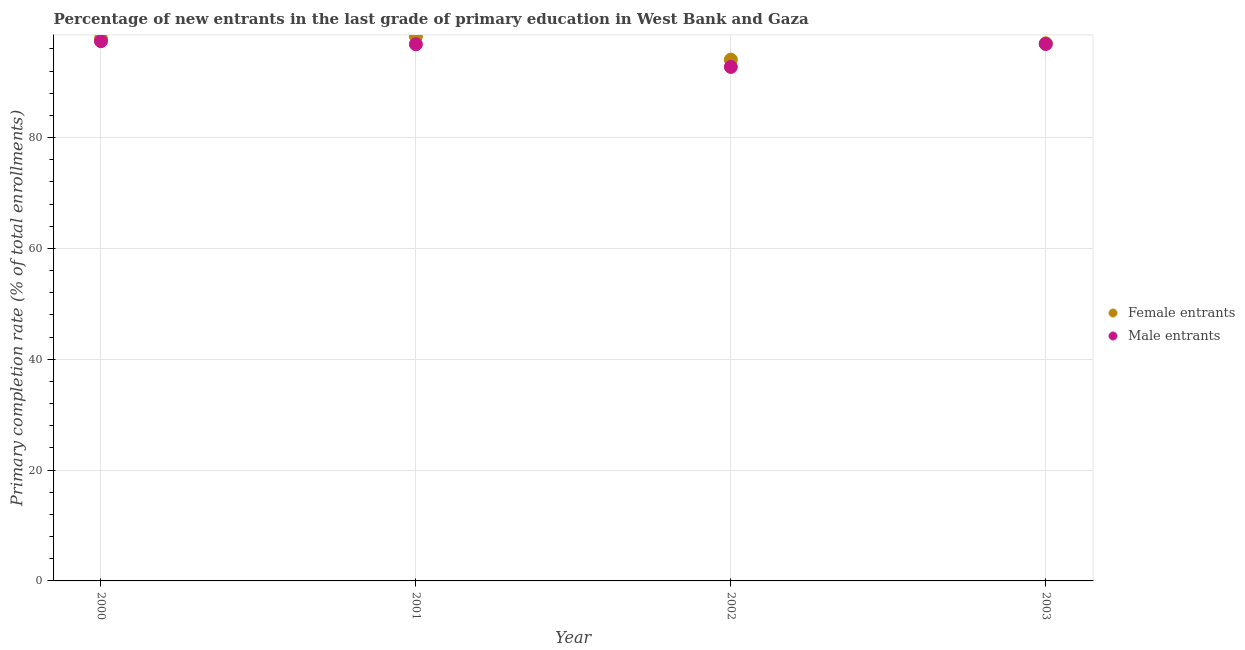What is the primary completion rate of male entrants in 2002?
Provide a short and direct response. 92.76. Across all years, what is the maximum primary completion rate of male entrants?
Provide a short and direct response. 97.41. Across all years, what is the minimum primary completion rate of female entrants?
Your answer should be compact. 94.08. In which year was the primary completion rate of male entrants maximum?
Provide a short and direct response. 2000. What is the total primary completion rate of female entrants in the graph?
Keep it short and to the point. 387.25. What is the difference between the primary completion rate of male entrants in 2000 and that in 2003?
Your response must be concise. 0.51. What is the difference between the primary completion rate of male entrants in 2001 and the primary completion rate of female entrants in 2000?
Your answer should be compact. -1.02. What is the average primary completion rate of female entrants per year?
Your answer should be very brief. 96.81. In the year 2000, what is the difference between the primary completion rate of male entrants and primary completion rate of female entrants?
Your answer should be very brief. -0.47. In how many years, is the primary completion rate of male entrants greater than 52 %?
Offer a very short reply. 4. What is the ratio of the primary completion rate of female entrants in 2001 to that in 2002?
Your answer should be compact. 1.04. Is the primary completion rate of female entrants in 2000 less than that in 2003?
Keep it short and to the point. No. Is the difference between the primary completion rate of female entrants in 2000 and 2001 greater than the difference between the primary completion rate of male entrants in 2000 and 2001?
Ensure brevity in your answer.  No. What is the difference between the highest and the second highest primary completion rate of female entrants?
Provide a succinct answer. 0.39. What is the difference between the highest and the lowest primary completion rate of female entrants?
Your answer should be compact. 4.19. In how many years, is the primary completion rate of male entrants greater than the average primary completion rate of male entrants taken over all years?
Offer a very short reply. 3. Is the sum of the primary completion rate of male entrants in 2000 and 2002 greater than the maximum primary completion rate of female entrants across all years?
Offer a very short reply. Yes. Is the primary completion rate of female entrants strictly less than the primary completion rate of male entrants over the years?
Keep it short and to the point. No. How many dotlines are there?
Give a very brief answer. 2. What is the difference between two consecutive major ticks on the Y-axis?
Your answer should be compact. 20. Are the values on the major ticks of Y-axis written in scientific E-notation?
Your answer should be very brief. No. Does the graph contain any zero values?
Ensure brevity in your answer.  No. Where does the legend appear in the graph?
Provide a succinct answer. Center right. How many legend labels are there?
Your answer should be compact. 2. What is the title of the graph?
Provide a succinct answer. Percentage of new entrants in the last grade of primary education in West Bank and Gaza. What is the label or title of the X-axis?
Give a very brief answer. Year. What is the label or title of the Y-axis?
Your answer should be very brief. Primary completion rate (% of total enrollments). What is the Primary completion rate (% of total enrollments) of Female entrants in 2000?
Offer a very short reply. 97.88. What is the Primary completion rate (% of total enrollments) in Male entrants in 2000?
Ensure brevity in your answer.  97.41. What is the Primary completion rate (% of total enrollments) of Female entrants in 2001?
Offer a terse response. 98.27. What is the Primary completion rate (% of total enrollments) of Male entrants in 2001?
Ensure brevity in your answer.  96.86. What is the Primary completion rate (% of total enrollments) in Female entrants in 2002?
Provide a succinct answer. 94.08. What is the Primary completion rate (% of total enrollments) in Male entrants in 2002?
Your answer should be very brief. 92.76. What is the Primary completion rate (% of total enrollments) of Female entrants in 2003?
Provide a succinct answer. 97.03. What is the Primary completion rate (% of total enrollments) in Male entrants in 2003?
Make the answer very short. 96.9. Across all years, what is the maximum Primary completion rate (% of total enrollments) of Female entrants?
Provide a succinct answer. 98.27. Across all years, what is the maximum Primary completion rate (% of total enrollments) of Male entrants?
Your response must be concise. 97.41. Across all years, what is the minimum Primary completion rate (% of total enrollments) in Female entrants?
Your answer should be very brief. 94.08. Across all years, what is the minimum Primary completion rate (% of total enrollments) of Male entrants?
Your answer should be compact. 92.76. What is the total Primary completion rate (% of total enrollments) of Female entrants in the graph?
Ensure brevity in your answer.  387.25. What is the total Primary completion rate (% of total enrollments) in Male entrants in the graph?
Your answer should be compact. 383.92. What is the difference between the Primary completion rate (% of total enrollments) in Female entrants in 2000 and that in 2001?
Provide a succinct answer. -0.39. What is the difference between the Primary completion rate (% of total enrollments) of Male entrants in 2000 and that in 2001?
Keep it short and to the point. 0.55. What is the difference between the Primary completion rate (% of total enrollments) in Female entrants in 2000 and that in 2002?
Your response must be concise. 3.8. What is the difference between the Primary completion rate (% of total enrollments) in Male entrants in 2000 and that in 2002?
Give a very brief answer. 4.64. What is the difference between the Primary completion rate (% of total enrollments) of Female entrants in 2000 and that in 2003?
Offer a terse response. 0.85. What is the difference between the Primary completion rate (% of total enrollments) in Male entrants in 2000 and that in 2003?
Offer a very short reply. 0.51. What is the difference between the Primary completion rate (% of total enrollments) in Female entrants in 2001 and that in 2002?
Offer a terse response. 4.19. What is the difference between the Primary completion rate (% of total enrollments) in Male entrants in 2001 and that in 2002?
Provide a succinct answer. 4.09. What is the difference between the Primary completion rate (% of total enrollments) of Female entrants in 2001 and that in 2003?
Provide a short and direct response. 1.25. What is the difference between the Primary completion rate (% of total enrollments) of Male entrants in 2001 and that in 2003?
Ensure brevity in your answer.  -0.04. What is the difference between the Primary completion rate (% of total enrollments) of Female entrants in 2002 and that in 2003?
Make the answer very short. -2.95. What is the difference between the Primary completion rate (% of total enrollments) in Male entrants in 2002 and that in 2003?
Your answer should be compact. -4.13. What is the difference between the Primary completion rate (% of total enrollments) of Female entrants in 2000 and the Primary completion rate (% of total enrollments) of Male entrants in 2001?
Offer a very short reply. 1.02. What is the difference between the Primary completion rate (% of total enrollments) of Female entrants in 2000 and the Primary completion rate (% of total enrollments) of Male entrants in 2002?
Keep it short and to the point. 5.11. What is the difference between the Primary completion rate (% of total enrollments) of Female entrants in 2000 and the Primary completion rate (% of total enrollments) of Male entrants in 2003?
Offer a terse response. 0.98. What is the difference between the Primary completion rate (% of total enrollments) of Female entrants in 2001 and the Primary completion rate (% of total enrollments) of Male entrants in 2002?
Your response must be concise. 5.51. What is the difference between the Primary completion rate (% of total enrollments) of Female entrants in 2001 and the Primary completion rate (% of total enrollments) of Male entrants in 2003?
Your answer should be compact. 1.38. What is the difference between the Primary completion rate (% of total enrollments) in Female entrants in 2002 and the Primary completion rate (% of total enrollments) in Male entrants in 2003?
Give a very brief answer. -2.82. What is the average Primary completion rate (% of total enrollments) of Female entrants per year?
Your response must be concise. 96.81. What is the average Primary completion rate (% of total enrollments) in Male entrants per year?
Your answer should be very brief. 95.98. In the year 2000, what is the difference between the Primary completion rate (% of total enrollments) of Female entrants and Primary completion rate (% of total enrollments) of Male entrants?
Ensure brevity in your answer.  0.47. In the year 2001, what is the difference between the Primary completion rate (% of total enrollments) in Female entrants and Primary completion rate (% of total enrollments) in Male entrants?
Offer a terse response. 1.42. In the year 2002, what is the difference between the Primary completion rate (% of total enrollments) in Female entrants and Primary completion rate (% of total enrollments) in Male entrants?
Your response must be concise. 1.31. In the year 2003, what is the difference between the Primary completion rate (% of total enrollments) of Female entrants and Primary completion rate (% of total enrollments) of Male entrants?
Keep it short and to the point. 0.13. What is the ratio of the Primary completion rate (% of total enrollments) in Male entrants in 2000 to that in 2001?
Your answer should be very brief. 1.01. What is the ratio of the Primary completion rate (% of total enrollments) of Female entrants in 2000 to that in 2002?
Ensure brevity in your answer.  1.04. What is the ratio of the Primary completion rate (% of total enrollments) in Male entrants in 2000 to that in 2002?
Give a very brief answer. 1.05. What is the ratio of the Primary completion rate (% of total enrollments) of Female entrants in 2000 to that in 2003?
Keep it short and to the point. 1.01. What is the ratio of the Primary completion rate (% of total enrollments) of Male entrants in 2000 to that in 2003?
Provide a short and direct response. 1.01. What is the ratio of the Primary completion rate (% of total enrollments) of Female entrants in 2001 to that in 2002?
Give a very brief answer. 1.04. What is the ratio of the Primary completion rate (% of total enrollments) in Male entrants in 2001 to that in 2002?
Provide a succinct answer. 1.04. What is the ratio of the Primary completion rate (% of total enrollments) in Female entrants in 2001 to that in 2003?
Provide a succinct answer. 1.01. What is the ratio of the Primary completion rate (% of total enrollments) in Female entrants in 2002 to that in 2003?
Provide a short and direct response. 0.97. What is the ratio of the Primary completion rate (% of total enrollments) in Male entrants in 2002 to that in 2003?
Offer a terse response. 0.96. What is the difference between the highest and the second highest Primary completion rate (% of total enrollments) of Female entrants?
Offer a very short reply. 0.39. What is the difference between the highest and the second highest Primary completion rate (% of total enrollments) in Male entrants?
Give a very brief answer. 0.51. What is the difference between the highest and the lowest Primary completion rate (% of total enrollments) of Female entrants?
Ensure brevity in your answer.  4.19. What is the difference between the highest and the lowest Primary completion rate (% of total enrollments) of Male entrants?
Offer a very short reply. 4.64. 